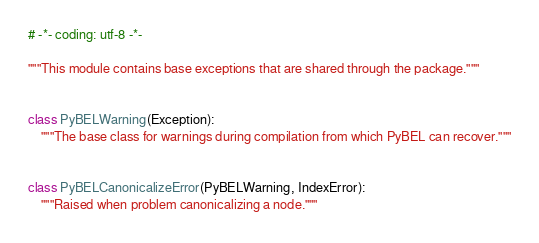Convert code to text. <code><loc_0><loc_0><loc_500><loc_500><_Python_># -*- coding: utf-8 -*-

"""This module contains base exceptions that are shared through the package."""


class PyBELWarning(Exception):
    """The base class for warnings during compilation from which PyBEL can recover."""


class PyBELCanonicalizeError(PyBELWarning, IndexError):
    """Raised when problem canonicalizing a node."""
</code> 